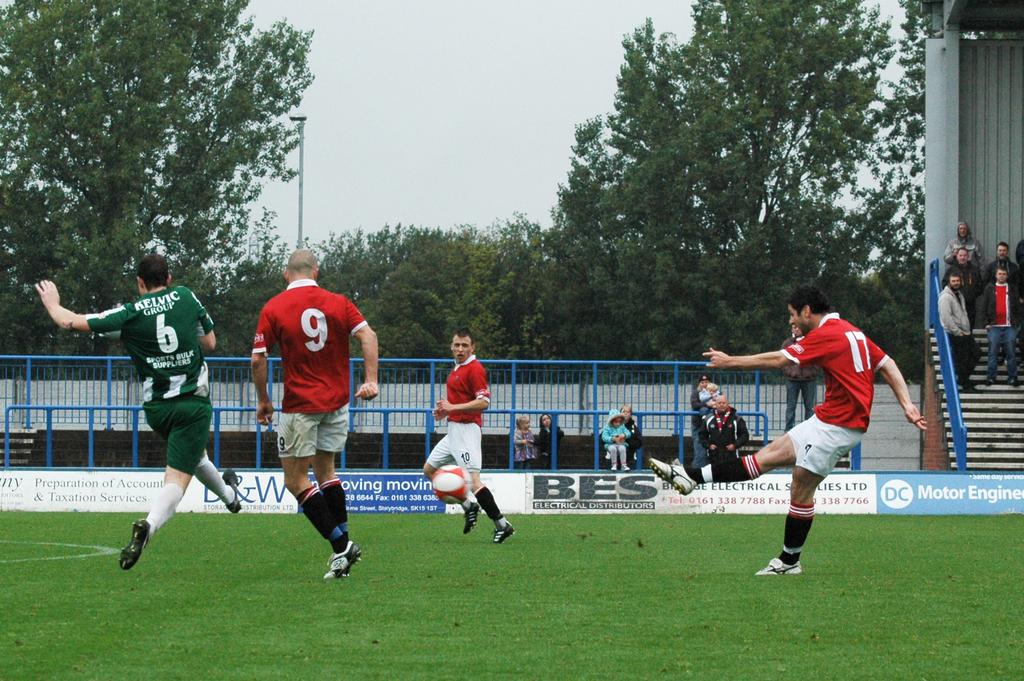What number is the man in red on the left?
Your answer should be very brief. 9. 